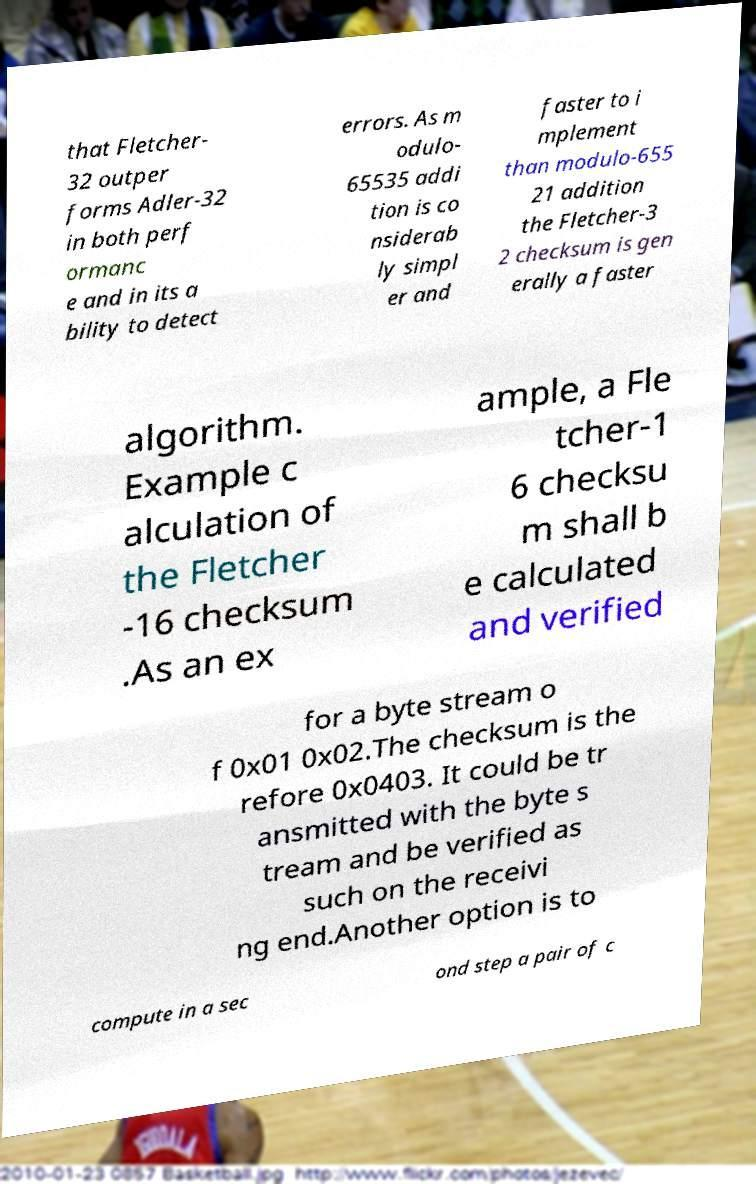There's text embedded in this image that I need extracted. Can you transcribe it verbatim? that Fletcher- 32 outper forms Adler-32 in both perf ormanc e and in its a bility to detect errors. As m odulo- 65535 addi tion is co nsiderab ly simpl er and faster to i mplement than modulo-655 21 addition the Fletcher-3 2 checksum is gen erally a faster algorithm. Example c alculation of the Fletcher -16 checksum .As an ex ample, a Fle tcher-1 6 checksu m shall b e calculated and verified for a byte stream o f 0x01 0x02.The checksum is the refore 0x0403. It could be tr ansmitted with the byte s tream and be verified as such on the receivi ng end.Another option is to compute in a sec ond step a pair of c 